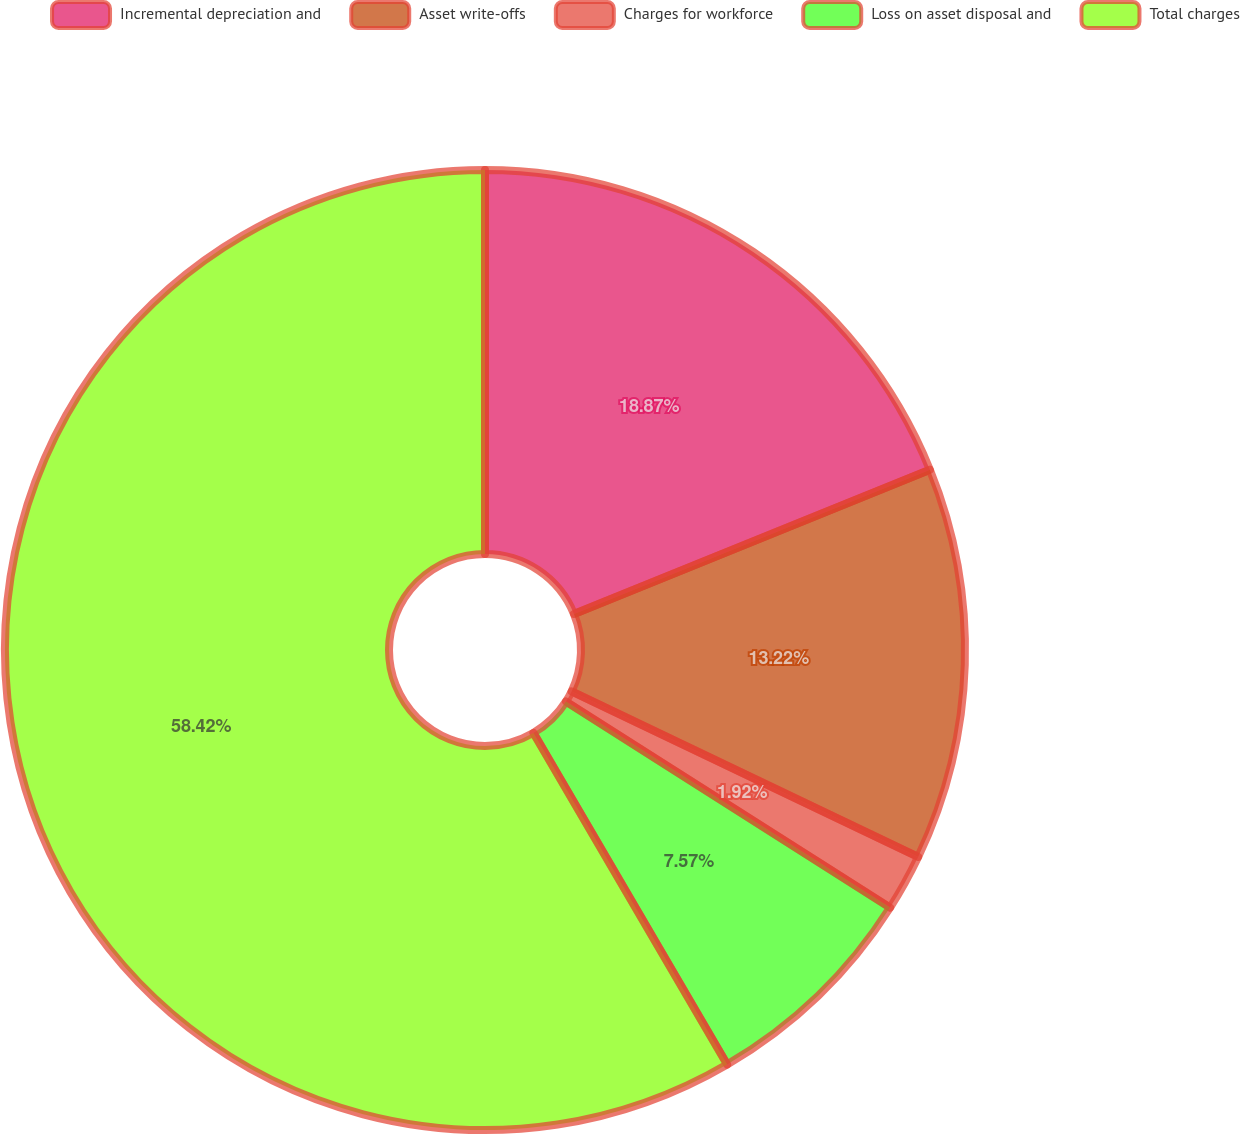Convert chart to OTSL. <chart><loc_0><loc_0><loc_500><loc_500><pie_chart><fcel>Incremental depreciation and<fcel>Asset write-offs<fcel>Charges for workforce<fcel>Loss on asset disposal and<fcel>Total charges<nl><fcel>18.87%<fcel>13.22%<fcel>1.92%<fcel>7.57%<fcel>58.41%<nl></chart> 